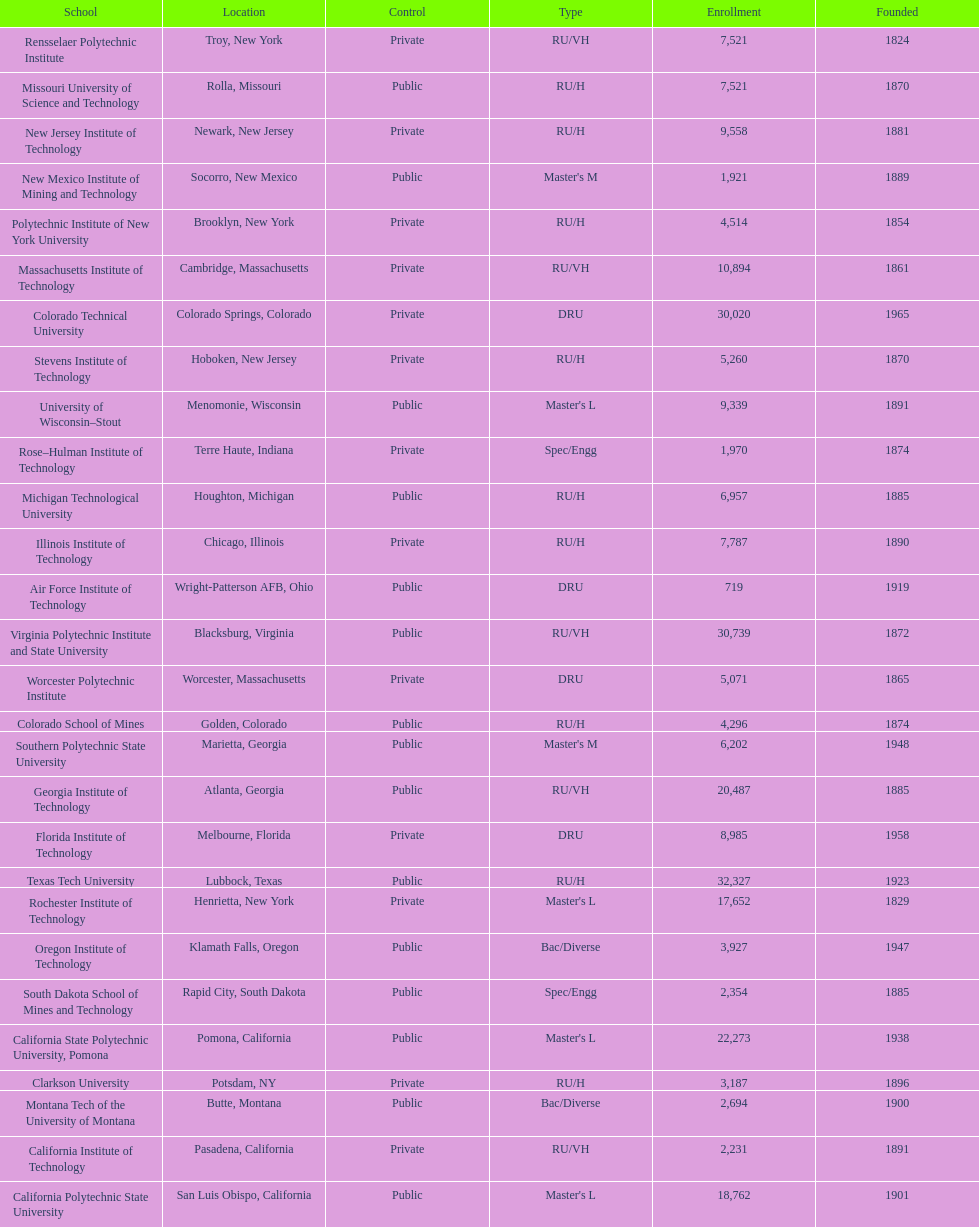Which of the universities was founded first? Rensselaer Polytechnic Institute. 